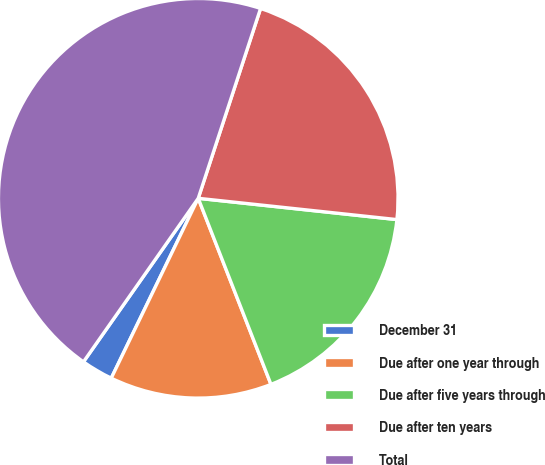<chart> <loc_0><loc_0><loc_500><loc_500><pie_chart><fcel>December 31<fcel>Due after one year through<fcel>Due after five years through<fcel>Due after ten years<fcel>Total<nl><fcel>2.57%<fcel>13.1%<fcel>17.37%<fcel>21.65%<fcel>45.31%<nl></chart> 